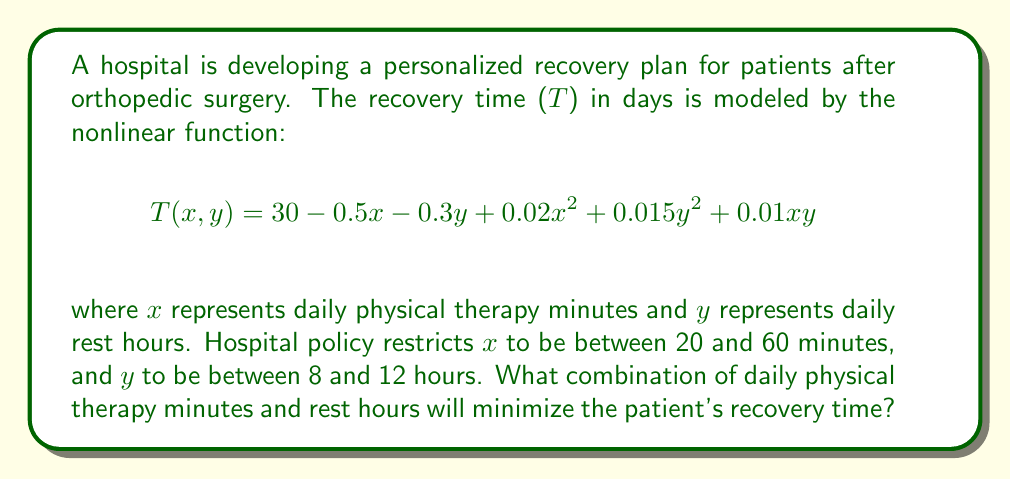Can you solve this math problem? To solve this nonlinear programming problem, we'll use the following steps:

1) First, we need to find the critical points by taking partial derivatives of T with respect to x and y, and setting them equal to zero:

   $$\frac{\partial T}{\partial x} = -0.5 + 0.04x + 0.01y = 0$$
   $$\frac{\partial T}{\partial y} = -0.3 + 0.03y + 0.01x = 0$$

2) Solving these equations simultaneously:
   
   From the first equation: $x = \frac{0.5 - 0.01y}{0.04} = 12.5 - 0.25y$
   
   Substituting this into the second equation:
   
   $-0.3 + 0.03y + 0.01(12.5 - 0.25y) = 0$
   $-0.3 + 0.03y + 0.125 - 0.0025y = 0$
   $0.0275y = 0.175$
   $y = 6.36$

   Substituting back:
   $x = 12.5 - 0.25(6.36) = 10.91$

3) However, this critical point (10.91, 6.36) is outside our constraints. Therefore, the minimum must occur on the boundary of our feasible region.

4) We need to check the corners of our feasible region:
   (20, 8), (20, 12), (60, 8), (60, 12)

   T(20, 8) = 30 - 10 - 2.4 + 8 + 0.96 + 1.6 = 28.16
   T(20, 12) = 30 - 10 - 3.6 + 8 + 2.16 + 2.4 = 28.96
   T(60, 8) = 30 - 30 - 2.4 + 72 + 0.96 + 4.8 = 75.36
   T(60, 12) = 30 - 30 - 3.6 + 72 + 2.16 + 7.2 = 77.76

5) The minimum value occurs at (20, 8), which represents 20 minutes of daily physical therapy and 8 hours of daily rest.
Answer: 20 minutes of daily physical therapy and 8 hours of daily rest 